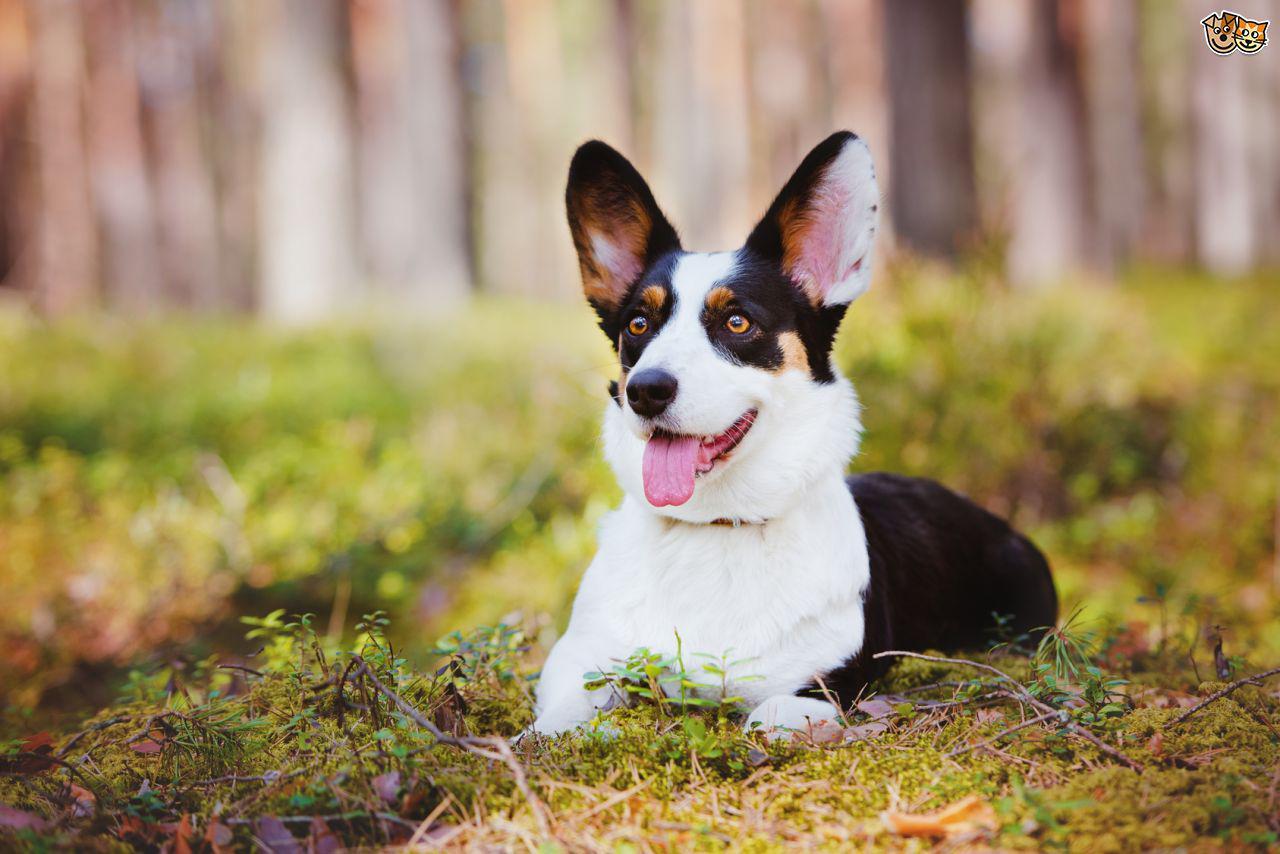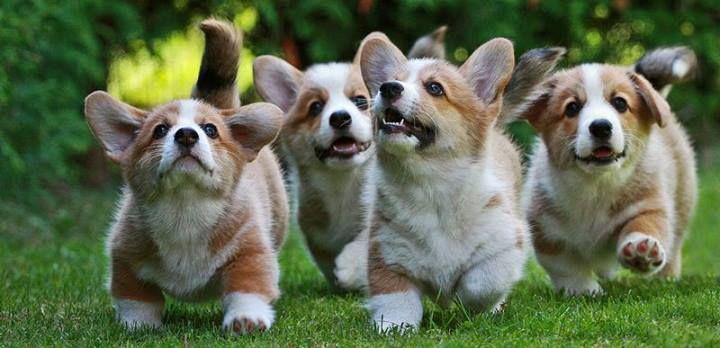The first image is the image on the left, the second image is the image on the right. Given the left and right images, does the statement "A single dog is standing in the grass in the image on the right." hold true? Answer yes or no. No. The first image is the image on the left, the second image is the image on the right. For the images displayed, is the sentence "Each image contains one short-legged corgi, and all dogs are posed on green grass." factually correct? Answer yes or no. No. 